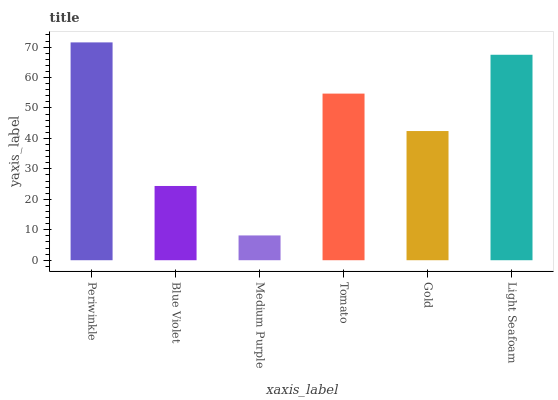Is Medium Purple the minimum?
Answer yes or no. Yes. Is Periwinkle the maximum?
Answer yes or no. Yes. Is Blue Violet the minimum?
Answer yes or no. No. Is Blue Violet the maximum?
Answer yes or no. No. Is Periwinkle greater than Blue Violet?
Answer yes or no. Yes. Is Blue Violet less than Periwinkle?
Answer yes or no. Yes. Is Blue Violet greater than Periwinkle?
Answer yes or no. No. Is Periwinkle less than Blue Violet?
Answer yes or no. No. Is Tomato the high median?
Answer yes or no. Yes. Is Gold the low median?
Answer yes or no. Yes. Is Gold the high median?
Answer yes or no. No. Is Medium Purple the low median?
Answer yes or no. No. 